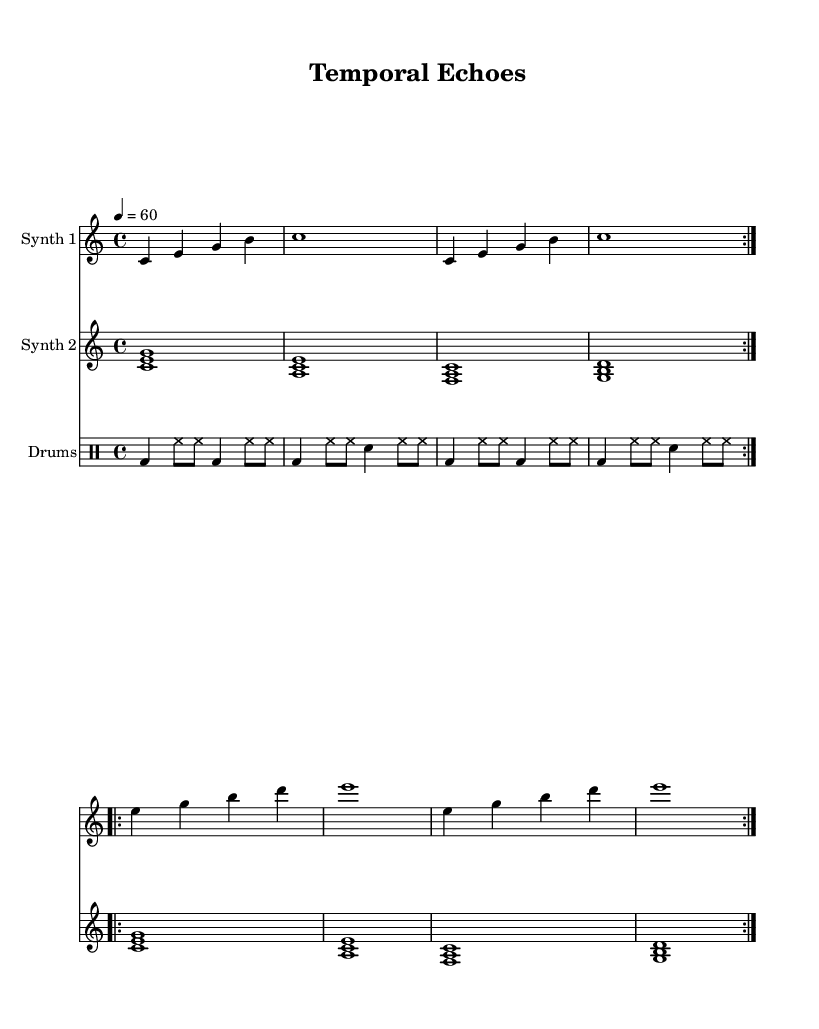What is the key signature of this music? The key signature is C major, which has no sharps or flats indicated on the staff.
Answer: C major What is the time signature of this music? The time signature is shown as 4/4, which means there are four beats per measure and a quarter note gets one beat.
Answer: 4/4 What is the tempo marking for this piece? The tempo marking is given as a quarter note equals 60 beats per minute, indicating the speed at which the music should be played.
Answer: 60 How many times does the first section of Synth 1 repeat? The first section of Synth 1 is marked to repeat twice, as indicated by the "volta 2" notation in the score.
Answer: 2 What is unique about the rhythm pattern in the drum part? The drum part alternates between bass drum and hi-hat, creating a consistent groove with a specific pattern that enhances the overall texture of the piece.
Answer: Alternating bass drum and hi-hat How many measures are included in the Synth 2 part? Each repeat of Synth 2 contains four measures, and since it repeats twice, the total is eight measures.
Answer: 8 What texture does this piece create by combining the two synths? The combination of synths creates a layered and ambient texture that evokes a sense of spaciousness and temporal progression, typical of minimalist electronic music.
Answer: Layered ambient texture 